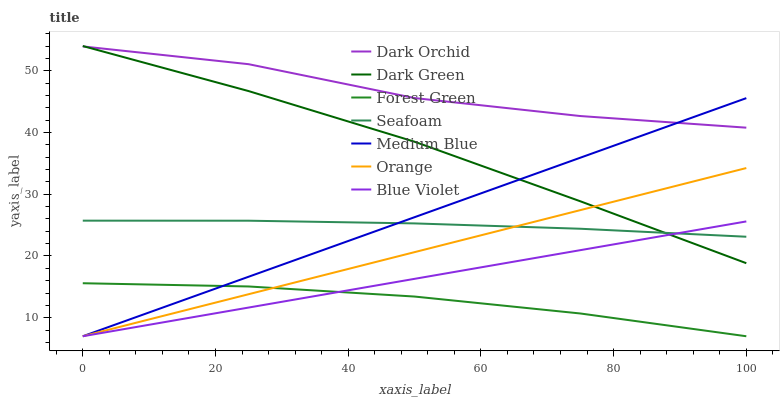Does Forest Green have the minimum area under the curve?
Answer yes or no. Yes. Does Dark Orchid have the maximum area under the curve?
Answer yes or no. Yes. Does Seafoam have the minimum area under the curve?
Answer yes or no. No. Does Seafoam have the maximum area under the curve?
Answer yes or no. No. Is Orange the smoothest?
Answer yes or no. Yes. Is Dark Orchid the roughest?
Answer yes or no. Yes. Is Seafoam the smoothest?
Answer yes or no. No. Is Seafoam the roughest?
Answer yes or no. No. Does Medium Blue have the lowest value?
Answer yes or no. Yes. Does Seafoam have the lowest value?
Answer yes or no. No. Does Dark Green have the highest value?
Answer yes or no. Yes. Does Seafoam have the highest value?
Answer yes or no. No. Is Orange less than Dark Orchid?
Answer yes or no. Yes. Is Dark Green greater than Forest Green?
Answer yes or no. Yes. Does Dark Green intersect Blue Violet?
Answer yes or no. Yes. Is Dark Green less than Blue Violet?
Answer yes or no. No. Is Dark Green greater than Blue Violet?
Answer yes or no. No. Does Orange intersect Dark Orchid?
Answer yes or no. No. 